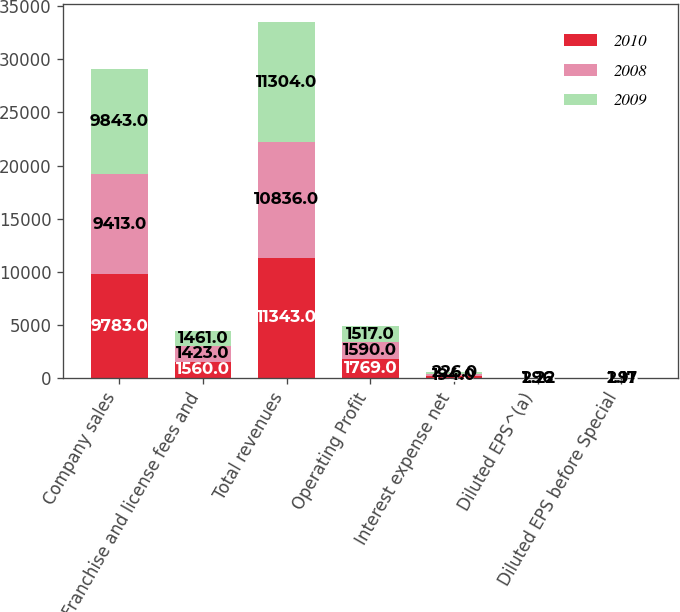Convert chart. <chart><loc_0><loc_0><loc_500><loc_500><stacked_bar_chart><ecel><fcel>Company sales<fcel>Franchise and license fees and<fcel>Total revenues<fcel>Operating Profit<fcel>Interest expense net<fcel>Diluted EPS^(a)<fcel>Diluted EPS before Special<nl><fcel>2010<fcel>9783<fcel>1560<fcel>11343<fcel>1769<fcel>175<fcel>2.38<fcel>2.53<nl><fcel>2008<fcel>9413<fcel>1423<fcel>10836<fcel>1590<fcel>194<fcel>2.22<fcel>2.17<nl><fcel>2009<fcel>9843<fcel>1461<fcel>11304<fcel>1517<fcel>226<fcel>1.96<fcel>1.91<nl></chart> 